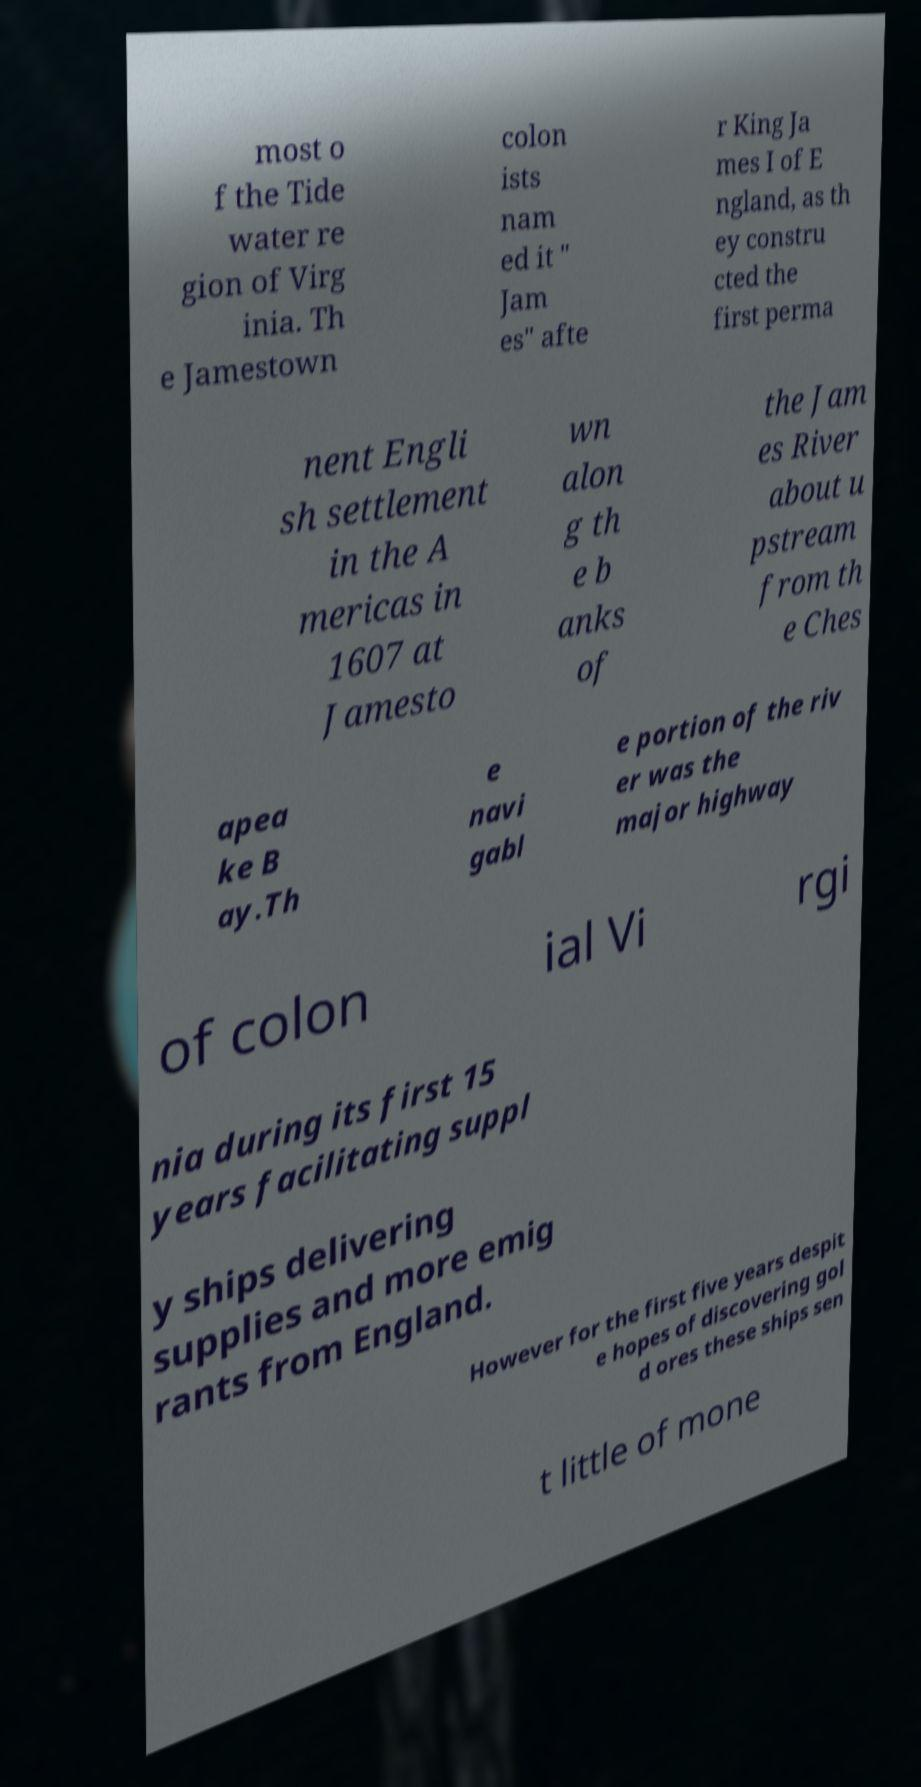Can you accurately transcribe the text from the provided image for me? most o f the Tide water re gion of Virg inia. Th e Jamestown colon ists nam ed it " Jam es" afte r King Ja mes I of E ngland, as th ey constru cted the first perma nent Engli sh settlement in the A mericas in 1607 at Jamesto wn alon g th e b anks of the Jam es River about u pstream from th e Ches apea ke B ay.Th e navi gabl e portion of the riv er was the major highway of colon ial Vi rgi nia during its first 15 years facilitating suppl y ships delivering supplies and more emig rants from England. However for the first five years despit e hopes of discovering gol d ores these ships sen t little of mone 